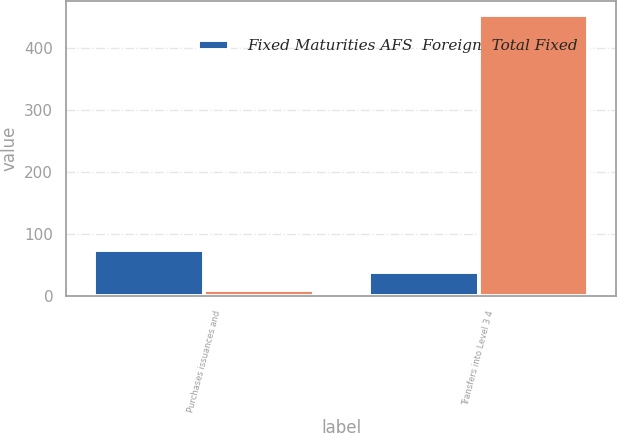Convert chart. <chart><loc_0><loc_0><loc_500><loc_500><stacked_bar_chart><ecel><fcel>Purchases issuances and<fcel>Transfers into Level 3 4<nl><fcel>Fixed Maturities AFS  Foreign  Total Fixed<fcel>74<fcel>40<nl><fcel>nan<fcel>11<fcel>453<nl></chart> 